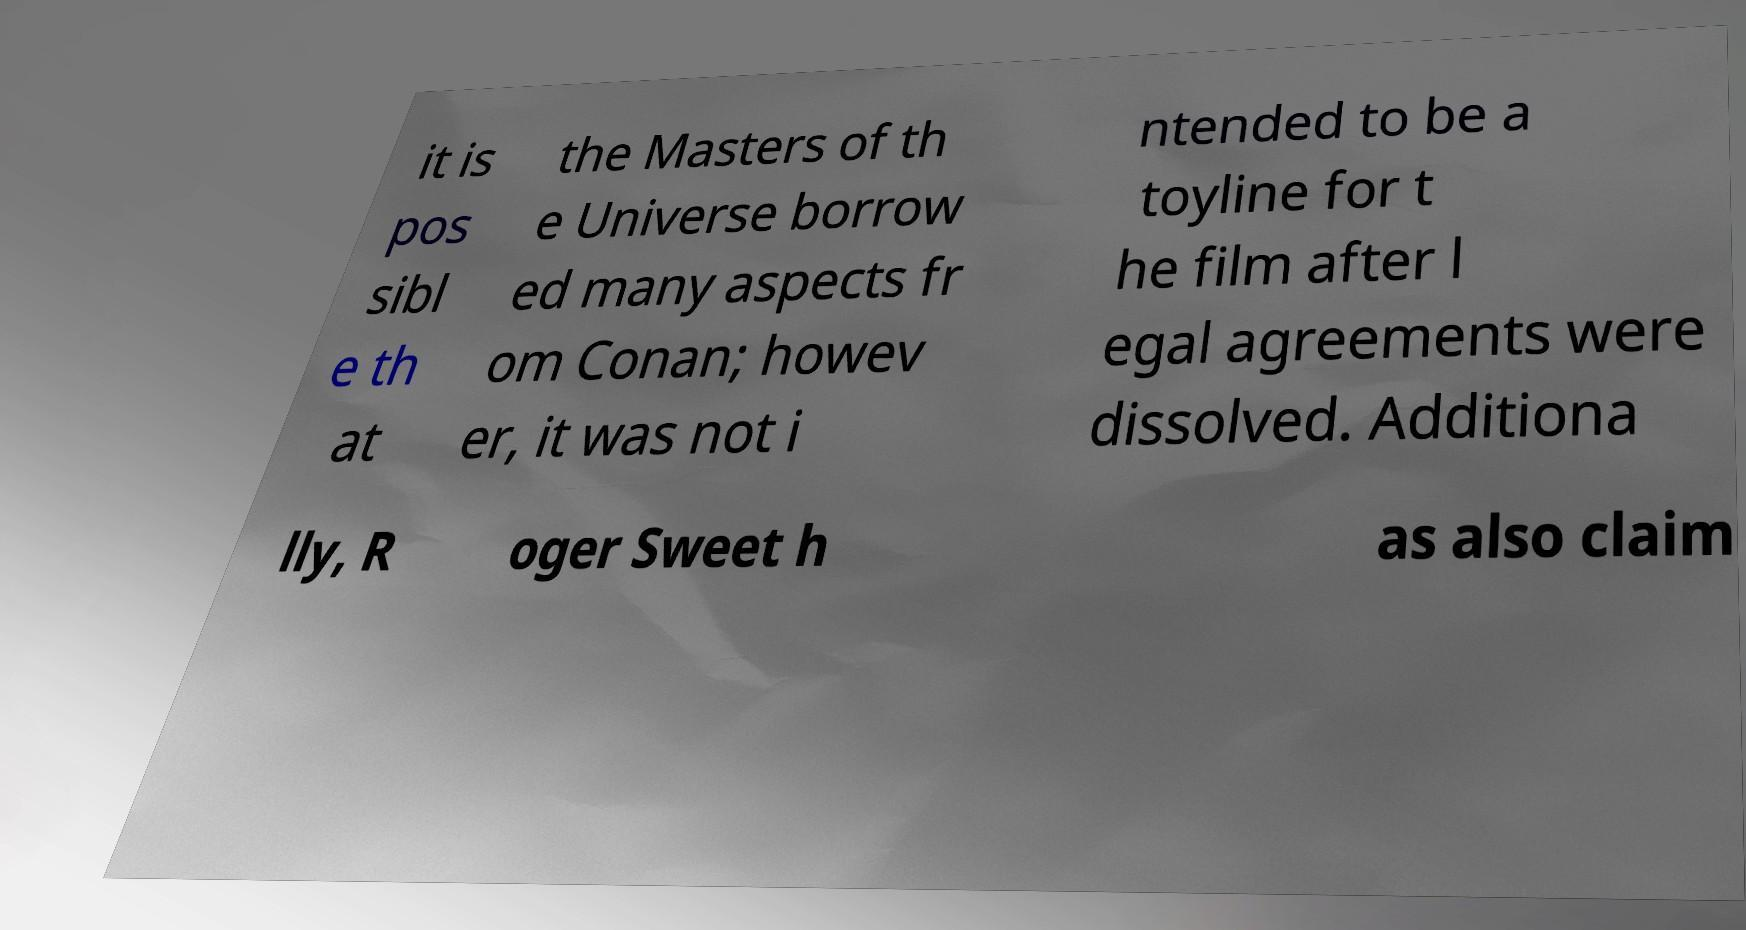What messages or text are displayed in this image? I need them in a readable, typed format. it is pos sibl e th at the Masters of th e Universe borrow ed many aspects fr om Conan; howev er, it was not i ntended to be a toyline for t he film after l egal agreements were dissolved. Additiona lly, R oger Sweet h as also claim 